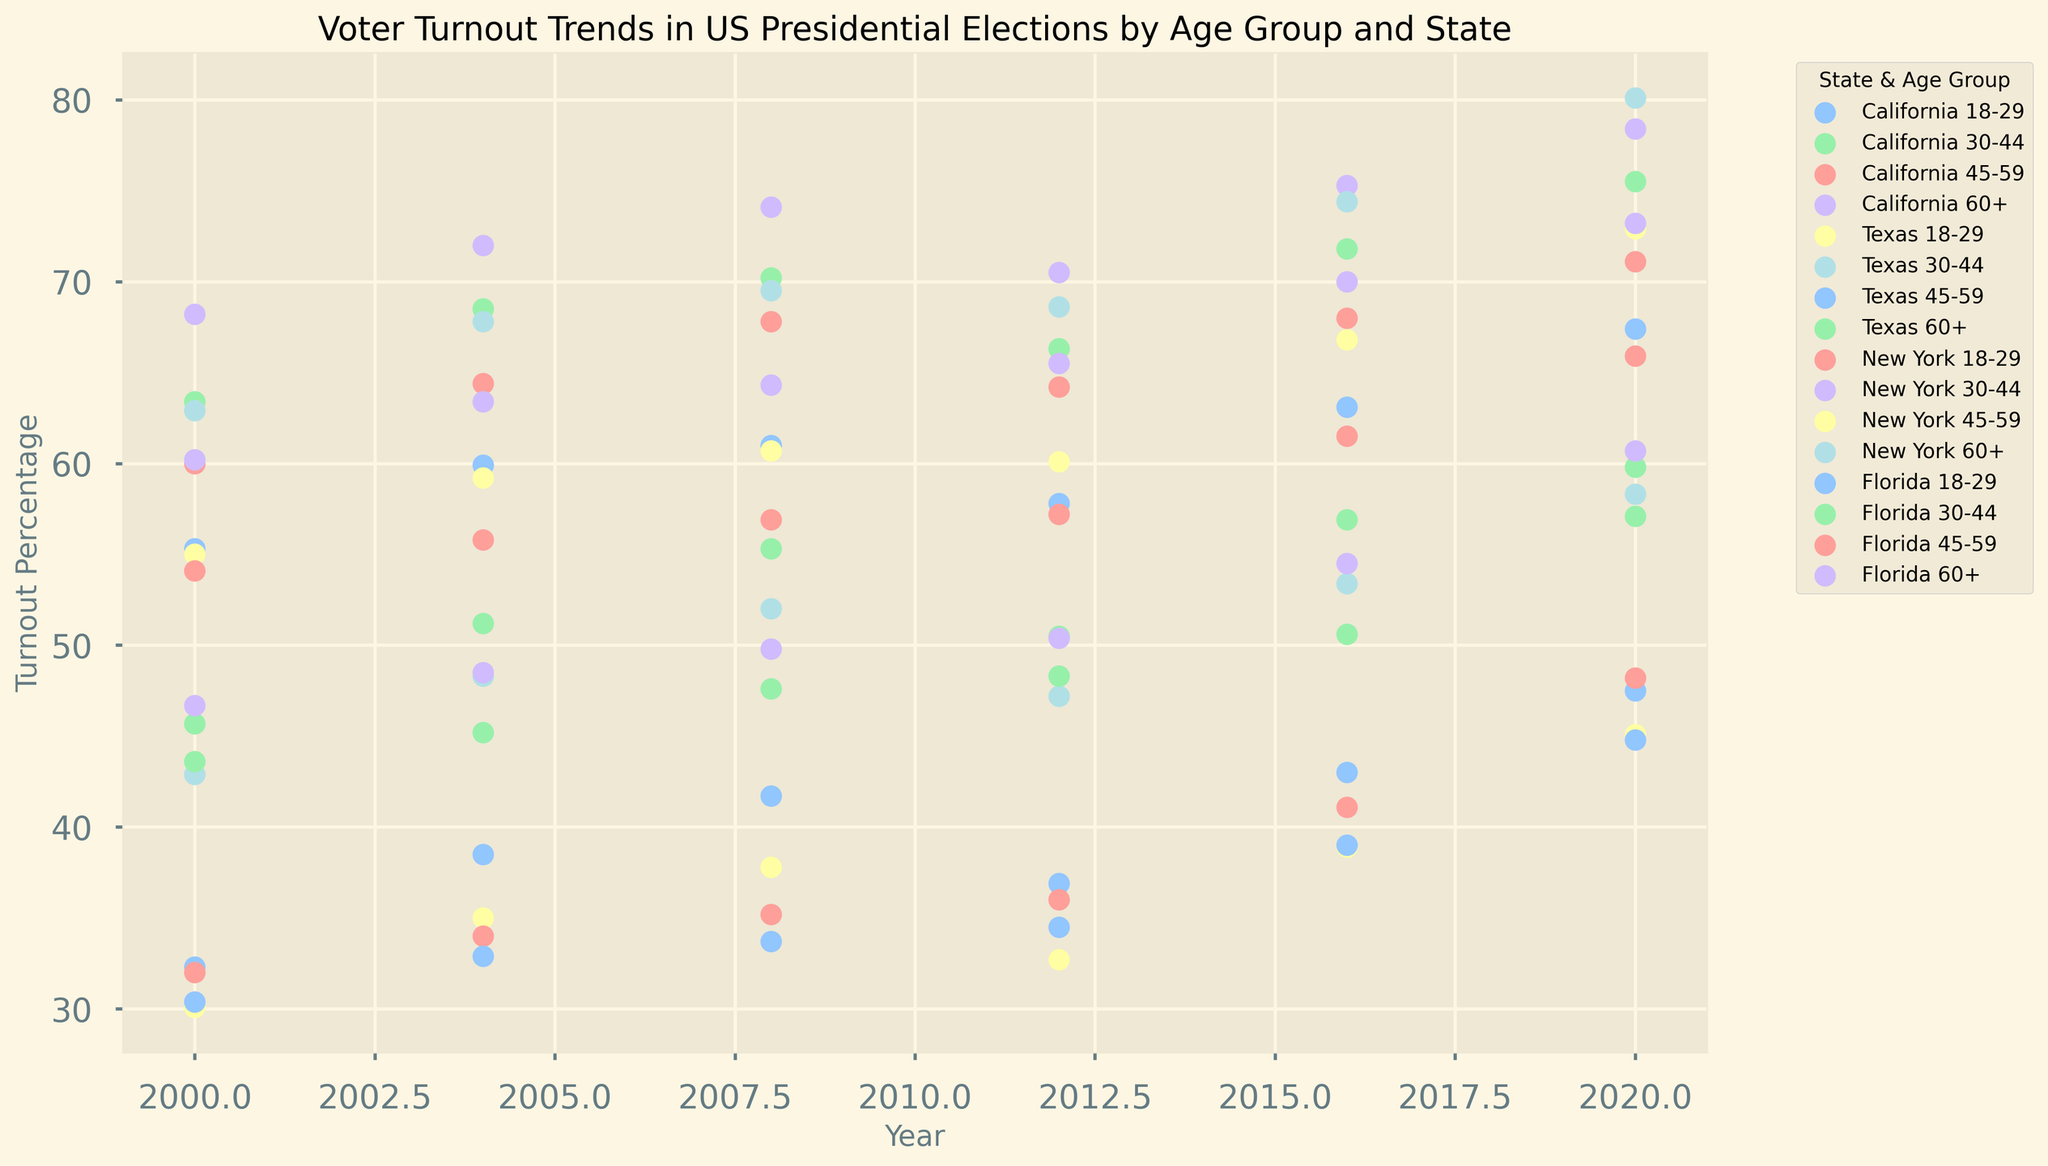Which state had the highest voter turnout percentage for the age group 60+ in 2020? Observe the plots for each state in 2020 and compare the voter turnout percentages for the age group 60+. New York shows the highest percentage.
Answer: New York How did the voter turnout percentage for the 18-29 age group in Texas compare between 2000 and 2020? Look at the scatter points for Texas for the years 2000 and 2020 within the 18-29 age group. In 2000, it's 30.1%, and in 2020, it's 45.1%. Hence, there's an increase.
Answer: Increased What was the average voter turnout percentage for the 45-59 age group in Florida across all noted years? Identify the turnout percentages for Florida's 45-59 age group from 2000 to 2020, which are: 54.1, 55.8, 56.9, 57.2, 61.5, 65.9. Compute their average: (54.1+55.8+56.9+57.2+61.5+65.9)/6 ≈ 58.57%
Answer: 58.57% Which age group had the most consistent voter turnout in California over the years shown? Examine the scatter points for each age group in California and observe their trends over the years. The age group 60+ has the most consistent gradual increase.
Answer: 60+ Between New York and Florida, which state had a higher voter turnout percentage for the 30-44 age group in 2016? Look at the scatter points for 30-44 age group in 2016. New York is 54.5% and Florida is 50.6%, so New York had a higher turnout.
Answer: New York Did voter turnout for the 30-44 age group in California increase or decrease between 2016 and 2020? By how much? Locate the voter turnout percentages for California's 30-44 age group for 2016 (56.9%) and 2020 (59.8%). Subtract 2020 percentage from 2016 percentage: 59.8% - 56.9% = 2.9%. There's an increase.
Answer: Increased by 2.9% What is the difference in voter turnout percentage for 18-29 age group between Texas and New York in 2020? Compare the scatter points for Texas and New York in 2020 for the 18-29 age group. Texas is at 45.1% and New York is at 48.2%. Subtract the Texas percentage from New York percentage: 48.2% - 45.1% = 3.1%.
Answer: 3.1% Which state had the largest increase in voter turnout percentage for any age group from 2000 to 2020? Identify and compare the voter turnout percentages for all states and age groups in 2000 and 2020. The highest observed increase is New York for 30-44 age group, from 46.7% to 60.7%, an increase of 14%.
Answer: New York, 30-44 age group By how much did voter turnout for the 45-59 age group in California change from 2008 to 2012? Look at the data points for California's 45-59 age group in 2008 (67.8%) and 2012 (64.2%). Subtract 2012 from 2008 percentage: 67.8% - 64.2% = 3.6%. There was a decrease.
Answer: Decreased by 3.6% 